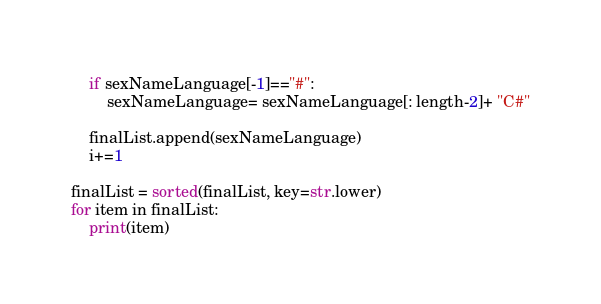<code> <loc_0><loc_0><loc_500><loc_500><_Python_>    if sexNameLanguage[-1]=="#":
        sexNameLanguage= sexNameLanguage[: length-2]+ "C#"

    finalList.append(sexNameLanguage)
    i+=1

finalList = sorted(finalList, key=str.lower)
for item in finalList:
    print(item)</code> 